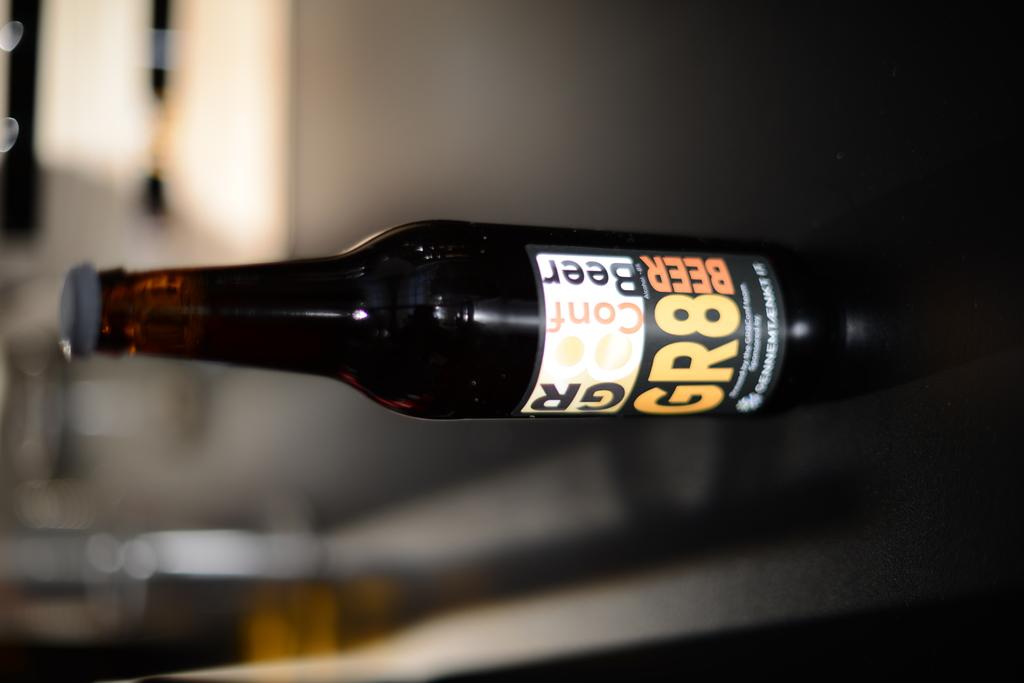What is the drink in the bottle?
Make the answer very short. Beer. 